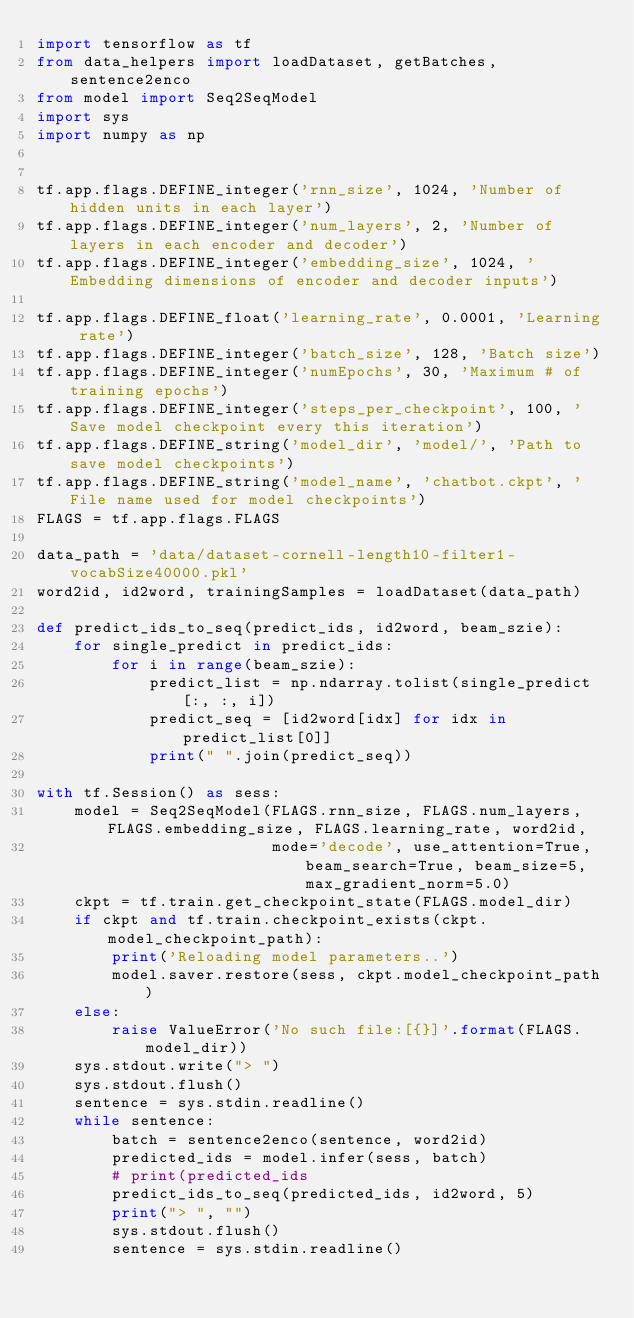<code> <loc_0><loc_0><loc_500><loc_500><_Python_>import tensorflow as tf
from data_helpers import loadDataset, getBatches, sentence2enco
from model import Seq2SeqModel
import sys
import numpy as np


tf.app.flags.DEFINE_integer('rnn_size', 1024, 'Number of hidden units in each layer')
tf.app.flags.DEFINE_integer('num_layers', 2, 'Number of layers in each encoder and decoder')
tf.app.flags.DEFINE_integer('embedding_size', 1024, 'Embedding dimensions of encoder and decoder inputs')

tf.app.flags.DEFINE_float('learning_rate', 0.0001, 'Learning rate')
tf.app.flags.DEFINE_integer('batch_size', 128, 'Batch size')
tf.app.flags.DEFINE_integer('numEpochs', 30, 'Maximum # of training epochs')
tf.app.flags.DEFINE_integer('steps_per_checkpoint', 100, 'Save model checkpoint every this iteration')
tf.app.flags.DEFINE_string('model_dir', 'model/', 'Path to save model checkpoints')
tf.app.flags.DEFINE_string('model_name', 'chatbot.ckpt', 'File name used for model checkpoints')
FLAGS = tf.app.flags.FLAGS

data_path = 'data/dataset-cornell-length10-filter1-vocabSize40000.pkl'
word2id, id2word, trainingSamples = loadDataset(data_path)

def predict_ids_to_seq(predict_ids, id2word, beam_szie):
    for single_predict in predict_ids:
        for i in range(beam_szie):
            predict_list = np.ndarray.tolist(single_predict[:, :, i])
            predict_seq = [id2word[idx] for idx in predict_list[0]]
            print(" ".join(predict_seq))

with tf.Session() as sess:
    model = Seq2SeqModel(FLAGS.rnn_size, FLAGS.num_layers, FLAGS.embedding_size, FLAGS.learning_rate, word2id,
                         mode='decode', use_attention=True, beam_search=True, beam_size=5, max_gradient_norm=5.0)
    ckpt = tf.train.get_checkpoint_state(FLAGS.model_dir)
    if ckpt and tf.train.checkpoint_exists(ckpt.model_checkpoint_path):
        print('Reloading model parameters..')
        model.saver.restore(sess, ckpt.model_checkpoint_path)
    else:
        raise ValueError('No such file:[{}]'.format(FLAGS.model_dir))
    sys.stdout.write("> ")
    sys.stdout.flush()
    sentence = sys.stdin.readline()
    while sentence:
        batch = sentence2enco(sentence, word2id)
        predicted_ids = model.infer(sess, batch)
        # print(predicted_ids
        predict_ids_to_seq(predicted_ids, id2word, 5)
        print("> ", "")
        sys.stdout.flush()
        sentence = sys.stdin.readline()
</code> 